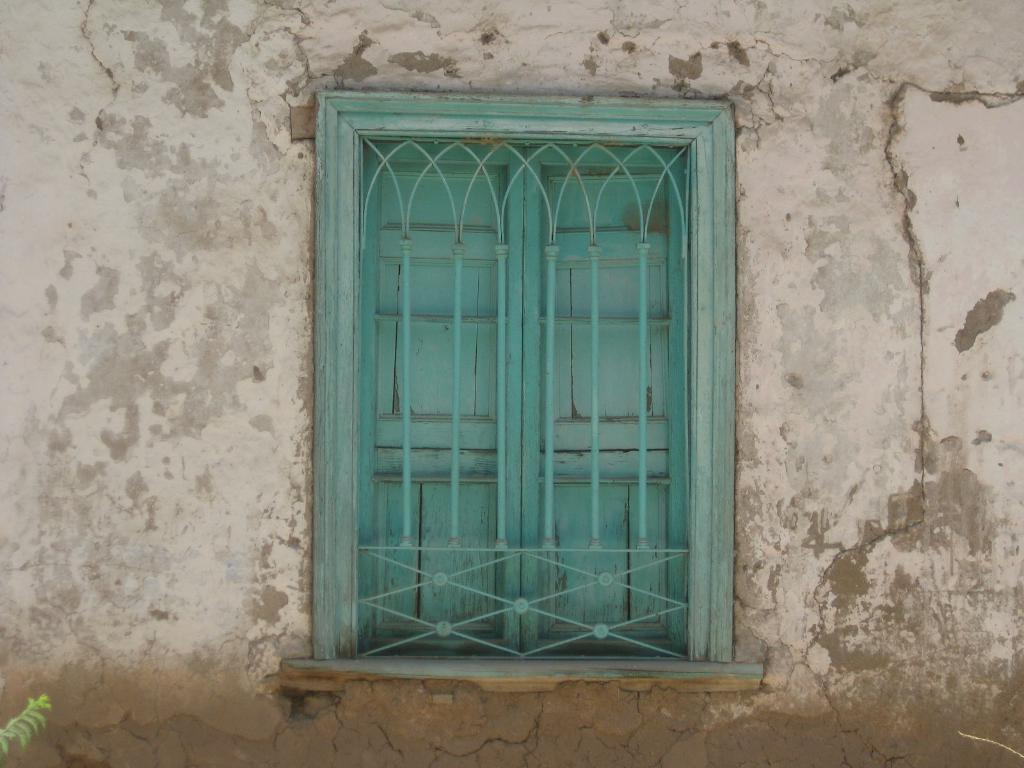What type of structure can be seen in the image? There is a wall in the image. What natural elements are present in the image? There are leaves in the image. What man-made objects can be seen in the image? There are rods in the image. What architectural feature is visible in the image? There is a window in the image. What type of soup is being prepared in the image? There is no soup present in the image. What type of scissors are being used to cut the leaves in the image? There are no scissors or cutting activity present in the image. 